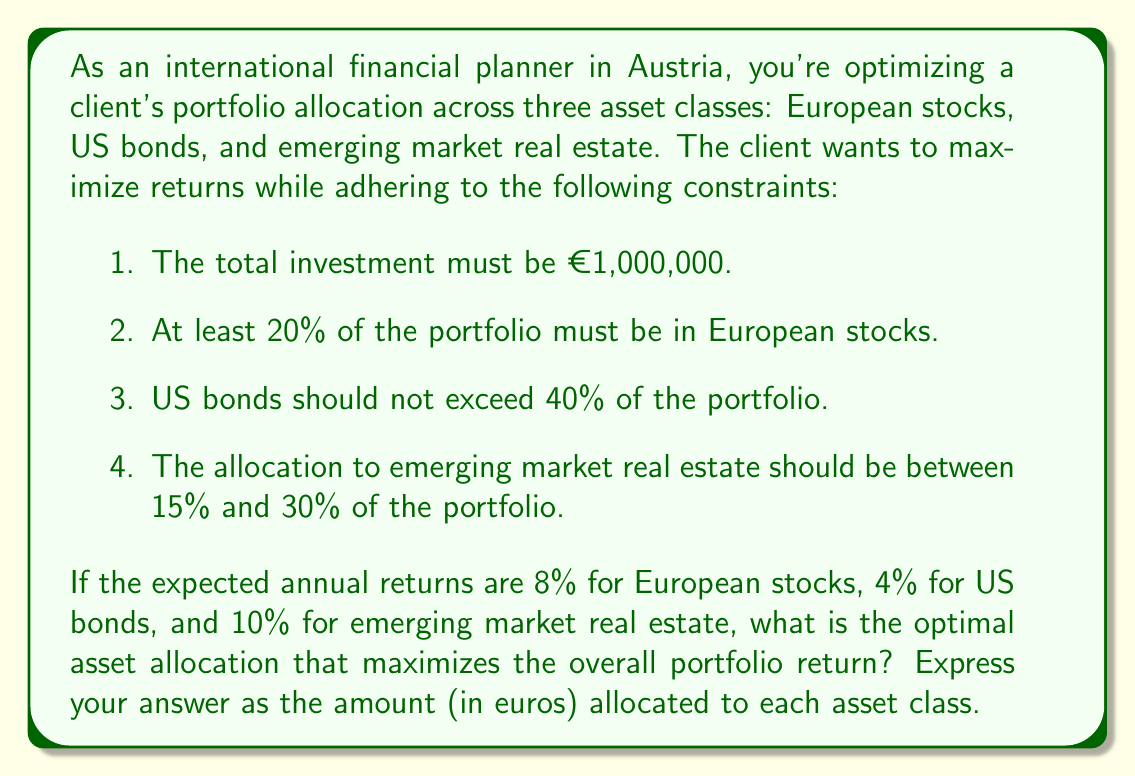Solve this math problem. Let's approach this step-by-step using a system of inequalities and linear programming:

1) Define variables:
   Let $x$ = European stocks
   Let $y$ = US bonds
   Let $z$ = Emerging market real estate

2) Set up the objective function to maximize:
   Maximize $0.08x + 0.04y + 0.10z$

3) Set up the constraints:
   a) Total investment: $x + y + z = 1,000,000$
   b) European stocks at least 20%: $x \geq 0.2(1,000,000)$ or $x \geq 200,000$
   c) US bonds not exceeding 40%: $y \leq 0.4(1,000,000)$ or $y \leq 400,000$
   d) Emerging market real estate between 15% and 30%:
      $0.15(1,000,000) \leq z \leq 0.3(1,000,000)$ or $150,000 \leq z \leq 300,000$

4) Solve the linear programming problem:
   The optimal solution will be at one of the vertices of the feasible region. We can find it by testing the vertices:

   Vertex 1: $x = 550,000$, $y = 300,000$, $z = 150,000$
   Return = $0.08(550,000) + 0.04(300,000) + 0.10(150,000) = 61,000$

   Vertex 2: $x = 450,000$, $y = 400,000$, $z = 150,000$
   Return = $0.08(450,000) + 0.04(400,000) + 0.10(150,000) = 61,000$

   Vertex 3: $x = 500,000$, $y = 200,000$, $z = 300,000$
   Return = $0.08(500,000) + 0.04(200,000) + 0.10(300,000) = 70,000$

   Vertex 4: $x = 400,000$, $y = 300,000$, $z = 300,000$
   Return = $0.08(400,000) + 0.04(300,000) + 0.10(300,000) = 64,000$

5) The maximum return is achieved at Vertex 3.
Answer: The optimal asset allocation that maximizes the portfolio return is:
European stocks: €500,000
US bonds: €200,000
Emerging market real estate: €300,000 